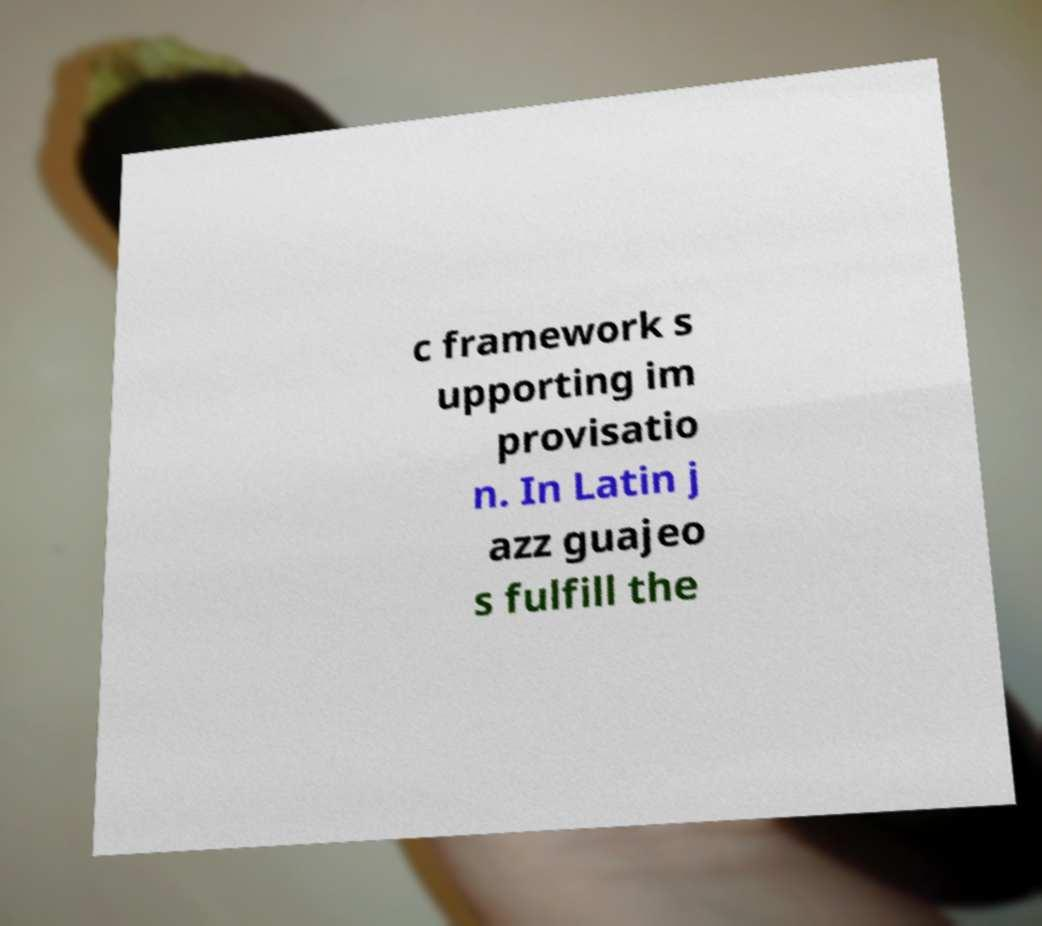Could you assist in decoding the text presented in this image and type it out clearly? c framework s upporting im provisatio n. In Latin j azz guajeo s fulfill the 